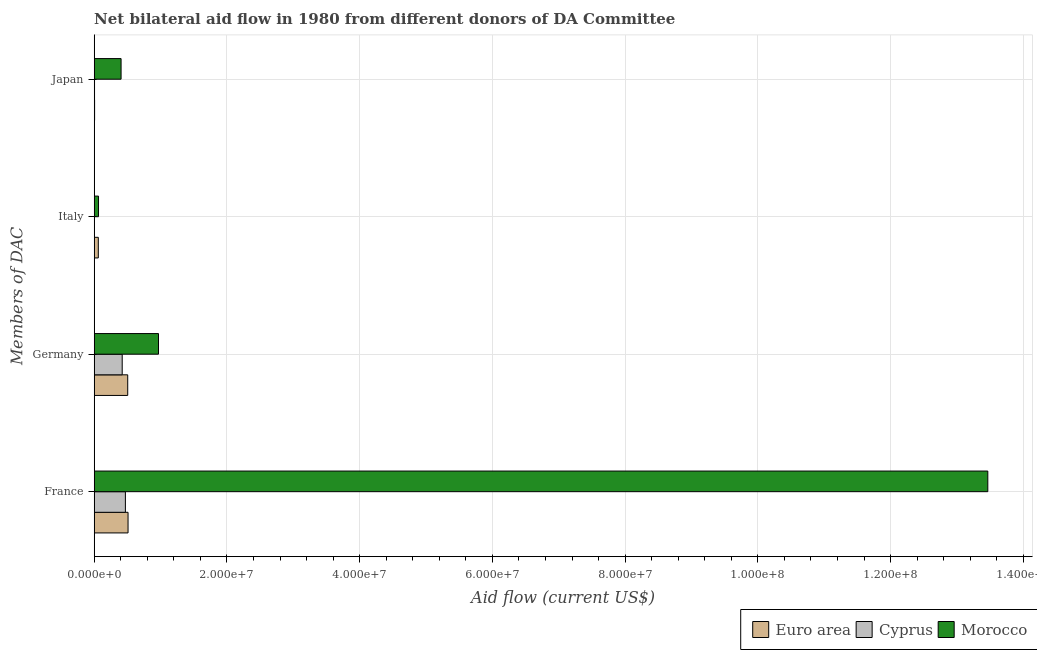How many different coloured bars are there?
Provide a short and direct response. 3. Are the number of bars on each tick of the Y-axis equal?
Your answer should be compact. Yes. What is the label of the 3rd group of bars from the top?
Keep it short and to the point. Germany. What is the amount of aid given by japan in Cyprus?
Make the answer very short. 5.00e+04. Across all countries, what is the maximum amount of aid given by japan?
Offer a terse response. 4.05e+06. Across all countries, what is the minimum amount of aid given by italy?
Provide a succinct answer. 3.00e+04. In which country was the amount of aid given by japan maximum?
Your answer should be very brief. Morocco. In which country was the amount of aid given by germany minimum?
Provide a succinct answer. Cyprus. What is the total amount of aid given by japan in the graph?
Provide a short and direct response. 4.16e+06. What is the difference between the amount of aid given by france in Euro area and that in Cyprus?
Your answer should be compact. 4.00e+05. What is the difference between the amount of aid given by japan in Euro area and the amount of aid given by italy in Morocco?
Your answer should be compact. -5.90e+05. What is the average amount of aid given by germany per country?
Give a very brief answer. 6.32e+06. What is the difference between the amount of aid given by italy and amount of aid given by japan in Cyprus?
Ensure brevity in your answer.  -2.00e+04. In how many countries, is the amount of aid given by italy greater than 40000000 US$?
Your answer should be compact. 0. What is the ratio of the amount of aid given by germany in Cyprus to that in Euro area?
Offer a terse response. 0.84. Is the amount of aid given by france in Cyprus less than that in Morocco?
Provide a succinct answer. Yes. Is the difference between the amount of aid given by germany in Euro area and Morocco greater than the difference between the amount of aid given by japan in Euro area and Morocco?
Give a very brief answer. No. What is the difference between the highest and the second highest amount of aid given by france?
Ensure brevity in your answer.  1.30e+08. What is the difference between the highest and the lowest amount of aid given by italy?
Offer a very short reply. 6.20e+05. In how many countries, is the amount of aid given by france greater than the average amount of aid given by france taken over all countries?
Ensure brevity in your answer.  1. Is it the case that in every country, the sum of the amount of aid given by japan and amount of aid given by france is greater than the sum of amount of aid given by italy and amount of aid given by germany?
Your answer should be compact. Yes. What does the 1st bar from the top in Japan represents?
Keep it short and to the point. Morocco. What does the 2nd bar from the bottom in France represents?
Give a very brief answer. Cyprus. Is it the case that in every country, the sum of the amount of aid given by france and amount of aid given by germany is greater than the amount of aid given by italy?
Give a very brief answer. Yes. How many bars are there?
Give a very brief answer. 12. Does the graph contain any zero values?
Your response must be concise. No. Where does the legend appear in the graph?
Keep it short and to the point. Bottom right. How are the legend labels stacked?
Make the answer very short. Horizontal. What is the title of the graph?
Your answer should be very brief. Net bilateral aid flow in 1980 from different donors of DA Committee. What is the label or title of the X-axis?
Offer a terse response. Aid flow (current US$). What is the label or title of the Y-axis?
Offer a terse response. Members of DAC. What is the Aid flow (current US$) in Euro area in France?
Your response must be concise. 5.10e+06. What is the Aid flow (current US$) of Cyprus in France?
Your answer should be compact. 4.70e+06. What is the Aid flow (current US$) of Morocco in France?
Provide a succinct answer. 1.35e+08. What is the Aid flow (current US$) in Euro area in Germany?
Your response must be concise. 5.05e+06. What is the Aid flow (current US$) of Cyprus in Germany?
Your answer should be compact. 4.22e+06. What is the Aid flow (current US$) of Morocco in Germany?
Keep it short and to the point. 9.69e+06. What is the Aid flow (current US$) in Euro area in Italy?
Provide a succinct answer. 6.20e+05. What is the Aid flow (current US$) of Cyprus in Italy?
Provide a succinct answer. 3.00e+04. What is the Aid flow (current US$) in Morocco in Italy?
Your answer should be very brief. 6.50e+05. What is the Aid flow (current US$) in Euro area in Japan?
Your answer should be very brief. 6.00e+04. What is the Aid flow (current US$) of Morocco in Japan?
Give a very brief answer. 4.05e+06. Across all Members of DAC, what is the maximum Aid flow (current US$) in Euro area?
Offer a very short reply. 5.10e+06. Across all Members of DAC, what is the maximum Aid flow (current US$) in Cyprus?
Offer a terse response. 4.70e+06. Across all Members of DAC, what is the maximum Aid flow (current US$) of Morocco?
Your response must be concise. 1.35e+08. Across all Members of DAC, what is the minimum Aid flow (current US$) of Euro area?
Give a very brief answer. 6.00e+04. Across all Members of DAC, what is the minimum Aid flow (current US$) in Cyprus?
Keep it short and to the point. 3.00e+04. Across all Members of DAC, what is the minimum Aid flow (current US$) of Morocco?
Ensure brevity in your answer.  6.50e+05. What is the total Aid flow (current US$) of Euro area in the graph?
Provide a short and direct response. 1.08e+07. What is the total Aid flow (current US$) of Cyprus in the graph?
Give a very brief answer. 9.00e+06. What is the total Aid flow (current US$) in Morocco in the graph?
Your answer should be very brief. 1.49e+08. What is the difference between the Aid flow (current US$) of Morocco in France and that in Germany?
Offer a terse response. 1.25e+08. What is the difference between the Aid flow (current US$) of Euro area in France and that in Italy?
Your response must be concise. 4.48e+06. What is the difference between the Aid flow (current US$) of Cyprus in France and that in Italy?
Offer a very short reply. 4.67e+06. What is the difference between the Aid flow (current US$) in Morocco in France and that in Italy?
Provide a short and direct response. 1.34e+08. What is the difference between the Aid flow (current US$) in Euro area in France and that in Japan?
Your answer should be very brief. 5.04e+06. What is the difference between the Aid flow (current US$) in Cyprus in France and that in Japan?
Ensure brevity in your answer.  4.65e+06. What is the difference between the Aid flow (current US$) of Morocco in France and that in Japan?
Ensure brevity in your answer.  1.31e+08. What is the difference between the Aid flow (current US$) in Euro area in Germany and that in Italy?
Your answer should be very brief. 4.43e+06. What is the difference between the Aid flow (current US$) of Cyprus in Germany and that in Italy?
Make the answer very short. 4.19e+06. What is the difference between the Aid flow (current US$) of Morocco in Germany and that in Italy?
Your response must be concise. 9.04e+06. What is the difference between the Aid flow (current US$) in Euro area in Germany and that in Japan?
Give a very brief answer. 4.99e+06. What is the difference between the Aid flow (current US$) of Cyprus in Germany and that in Japan?
Keep it short and to the point. 4.17e+06. What is the difference between the Aid flow (current US$) in Morocco in Germany and that in Japan?
Provide a short and direct response. 5.64e+06. What is the difference between the Aid flow (current US$) in Euro area in Italy and that in Japan?
Provide a succinct answer. 5.60e+05. What is the difference between the Aid flow (current US$) in Morocco in Italy and that in Japan?
Provide a short and direct response. -3.40e+06. What is the difference between the Aid flow (current US$) of Euro area in France and the Aid flow (current US$) of Cyprus in Germany?
Provide a short and direct response. 8.80e+05. What is the difference between the Aid flow (current US$) in Euro area in France and the Aid flow (current US$) in Morocco in Germany?
Offer a terse response. -4.59e+06. What is the difference between the Aid flow (current US$) in Cyprus in France and the Aid flow (current US$) in Morocco in Germany?
Keep it short and to the point. -4.99e+06. What is the difference between the Aid flow (current US$) of Euro area in France and the Aid flow (current US$) of Cyprus in Italy?
Your answer should be very brief. 5.07e+06. What is the difference between the Aid flow (current US$) in Euro area in France and the Aid flow (current US$) in Morocco in Italy?
Your response must be concise. 4.45e+06. What is the difference between the Aid flow (current US$) of Cyprus in France and the Aid flow (current US$) of Morocco in Italy?
Offer a terse response. 4.05e+06. What is the difference between the Aid flow (current US$) of Euro area in France and the Aid flow (current US$) of Cyprus in Japan?
Your response must be concise. 5.05e+06. What is the difference between the Aid flow (current US$) of Euro area in France and the Aid flow (current US$) of Morocco in Japan?
Your response must be concise. 1.05e+06. What is the difference between the Aid flow (current US$) of Cyprus in France and the Aid flow (current US$) of Morocco in Japan?
Provide a succinct answer. 6.50e+05. What is the difference between the Aid flow (current US$) in Euro area in Germany and the Aid flow (current US$) in Cyprus in Italy?
Offer a terse response. 5.02e+06. What is the difference between the Aid flow (current US$) of Euro area in Germany and the Aid flow (current US$) of Morocco in Italy?
Make the answer very short. 4.40e+06. What is the difference between the Aid flow (current US$) of Cyprus in Germany and the Aid flow (current US$) of Morocco in Italy?
Offer a very short reply. 3.57e+06. What is the difference between the Aid flow (current US$) of Euro area in Germany and the Aid flow (current US$) of Cyprus in Japan?
Provide a succinct answer. 5.00e+06. What is the difference between the Aid flow (current US$) in Euro area in Germany and the Aid flow (current US$) in Morocco in Japan?
Make the answer very short. 1.00e+06. What is the difference between the Aid flow (current US$) of Cyprus in Germany and the Aid flow (current US$) of Morocco in Japan?
Ensure brevity in your answer.  1.70e+05. What is the difference between the Aid flow (current US$) in Euro area in Italy and the Aid flow (current US$) in Cyprus in Japan?
Give a very brief answer. 5.70e+05. What is the difference between the Aid flow (current US$) of Euro area in Italy and the Aid flow (current US$) of Morocco in Japan?
Make the answer very short. -3.43e+06. What is the difference between the Aid flow (current US$) in Cyprus in Italy and the Aid flow (current US$) in Morocco in Japan?
Your response must be concise. -4.02e+06. What is the average Aid flow (current US$) in Euro area per Members of DAC?
Offer a very short reply. 2.71e+06. What is the average Aid flow (current US$) of Cyprus per Members of DAC?
Keep it short and to the point. 2.25e+06. What is the average Aid flow (current US$) in Morocco per Members of DAC?
Provide a short and direct response. 3.73e+07. What is the difference between the Aid flow (current US$) of Euro area and Aid flow (current US$) of Morocco in France?
Give a very brief answer. -1.30e+08. What is the difference between the Aid flow (current US$) of Cyprus and Aid flow (current US$) of Morocco in France?
Your answer should be very brief. -1.30e+08. What is the difference between the Aid flow (current US$) of Euro area and Aid flow (current US$) of Cyprus in Germany?
Your response must be concise. 8.30e+05. What is the difference between the Aid flow (current US$) in Euro area and Aid flow (current US$) in Morocco in Germany?
Your answer should be very brief. -4.64e+06. What is the difference between the Aid flow (current US$) of Cyprus and Aid flow (current US$) of Morocco in Germany?
Provide a short and direct response. -5.47e+06. What is the difference between the Aid flow (current US$) in Euro area and Aid flow (current US$) in Cyprus in Italy?
Keep it short and to the point. 5.90e+05. What is the difference between the Aid flow (current US$) in Euro area and Aid flow (current US$) in Morocco in Italy?
Offer a very short reply. -3.00e+04. What is the difference between the Aid flow (current US$) of Cyprus and Aid flow (current US$) of Morocco in Italy?
Keep it short and to the point. -6.20e+05. What is the difference between the Aid flow (current US$) in Euro area and Aid flow (current US$) in Morocco in Japan?
Keep it short and to the point. -3.99e+06. What is the ratio of the Aid flow (current US$) in Euro area in France to that in Germany?
Make the answer very short. 1.01. What is the ratio of the Aid flow (current US$) of Cyprus in France to that in Germany?
Offer a terse response. 1.11. What is the ratio of the Aid flow (current US$) of Morocco in France to that in Germany?
Your response must be concise. 13.9. What is the ratio of the Aid flow (current US$) in Euro area in France to that in Italy?
Keep it short and to the point. 8.23. What is the ratio of the Aid flow (current US$) of Cyprus in France to that in Italy?
Give a very brief answer. 156.67. What is the ratio of the Aid flow (current US$) in Morocco in France to that in Italy?
Ensure brevity in your answer.  207.15. What is the ratio of the Aid flow (current US$) of Euro area in France to that in Japan?
Offer a terse response. 85. What is the ratio of the Aid flow (current US$) of Cyprus in France to that in Japan?
Keep it short and to the point. 94. What is the ratio of the Aid flow (current US$) of Morocco in France to that in Japan?
Keep it short and to the point. 33.25. What is the ratio of the Aid flow (current US$) of Euro area in Germany to that in Italy?
Provide a short and direct response. 8.15. What is the ratio of the Aid flow (current US$) of Cyprus in Germany to that in Italy?
Provide a short and direct response. 140.67. What is the ratio of the Aid flow (current US$) of Morocco in Germany to that in Italy?
Your answer should be compact. 14.91. What is the ratio of the Aid flow (current US$) in Euro area in Germany to that in Japan?
Ensure brevity in your answer.  84.17. What is the ratio of the Aid flow (current US$) in Cyprus in Germany to that in Japan?
Provide a short and direct response. 84.4. What is the ratio of the Aid flow (current US$) of Morocco in Germany to that in Japan?
Your response must be concise. 2.39. What is the ratio of the Aid flow (current US$) in Euro area in Italy to that in Japan?
Keep it short and to the point. 10.33. What is the ratio of the Aid flow (current US$) of Cyprus in Italy to that in Japan?
Keep it short and to the point. 0.6. What is the ratio of the Aid flow (current US$) in Morocco in Italy to that in Japan?
Make the answer very short. 0.16. What is the difference between the highest and the second highest Aid flow (current US$) of Euro area?
Keep it short and to the point. 5.00e+04. What is the difference between the highest and the second highest Aid flow (current US$) of Cyprus?
Ensure brevity in your answer.  4.80e+05. What is the difference between the highest and the second highest Aid flow (current US$) in Morocco?
Your response must be concise. 1.25e+08. What is the difference between the highest and the lowest Aid flow (current US$) in Euro area?
Offer a very short reply. 5.04e+06. What is the difference between the highest and the lowest Aid flow (current US$) in Cyprus?
Your answer should be compact. 4.67e+06. What is the difference between the highest and the lowest Aid flow (current US$) in Morocco?
Ensure brevity in your answer.  1.34e+08. 